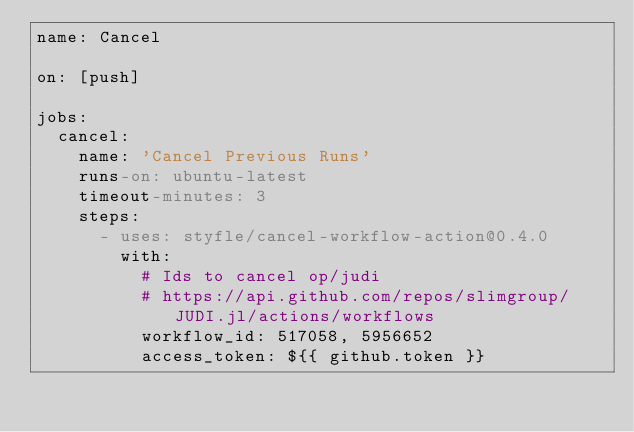<code> <loc_0><loc_0><loc_500><loc_500><_YAML_>name: Cancel

on: [push]

jobs:
  cancel:
    name: 'Cancel Previous Runs'
    runs-on: ubuntu-latest
    timeout-minutes: 3
    steps:
      - uses: styfle/cancel-workflow-action@0.4.0
        with:
          # Ids to cancel op/judi
          # https://api.github.com/repos/slimgroup/JUDI.jl/actions/workflows
          workflow_id: 517058, 5956652
          access_token: ${{ github.token }}</code> 